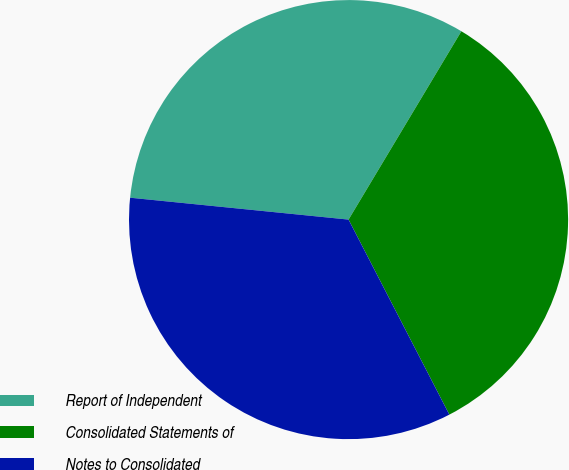<chart> <loc_0><loc_0><loc_500><loc_500><pie_chart><fcel>Report of Independent<fcel>Consolidated Statements of<fcel>Notes to Consolidated<nl><fcel>32.0%<fcel>33.82%<fcel>34.18%<nl></chart> 